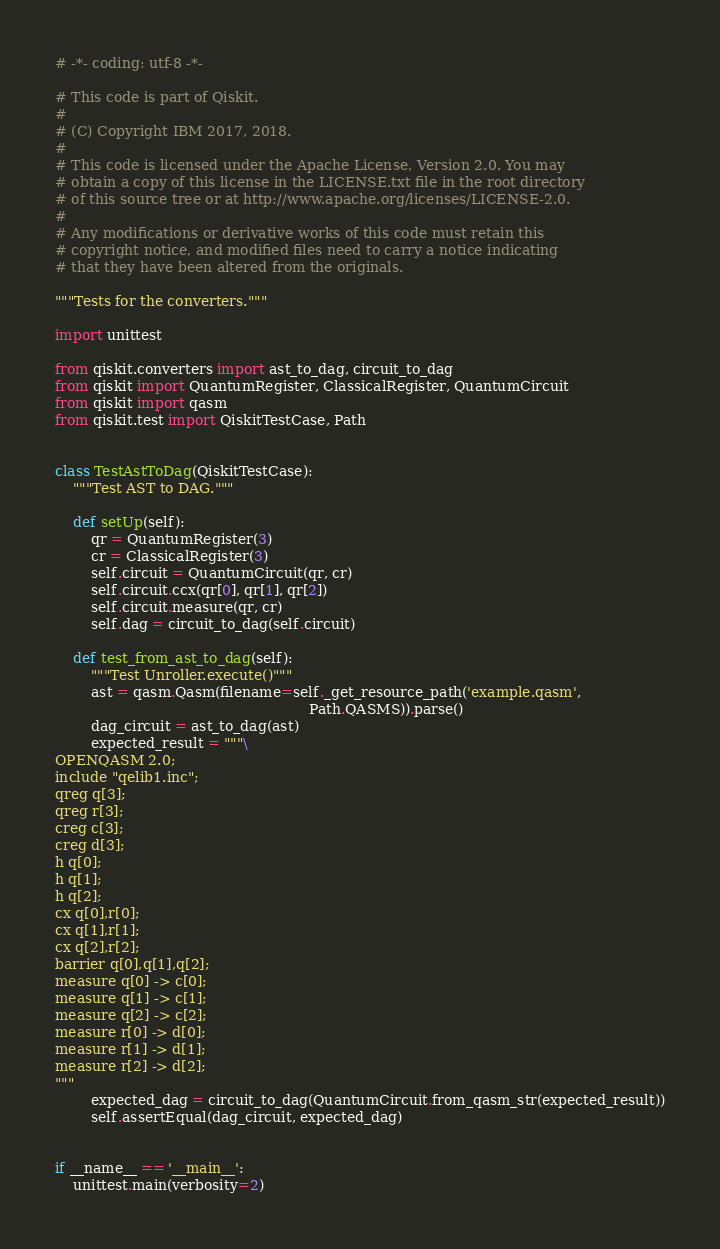Convert code to text. <code><loc_0><loc_0><loc_500><loc_500><_Python_># -*- coding: utf-8 -*-

# This code is part of Qiskit.
#
# (C) Copyright IBM 2017, 2018.
#
# This code is licensed under the Apache License, Version 2.0. You may
# obtain a copy of this license in the LICENSE.txt file in the root directory
# of this source tree or at http://www.apache.org/licenses/LICENSE-2.0.
#
# Any modifications or derivative works of this code must retain this
# copyright notice, and modified files need to carry a notice indicating
# that they have been altered from the originals.

"""Tests for the converters."""

import unittest

from qiskit.converters import ast_to_dag, circuit_to_dag
from qiskit import QuantumRegister, ClassicalRegister, QuantumCircuit
from qiskit import qasm
from qiskit.test import QiskitTestCase, Path


class TestAstToDag(QiskitTestCase):
    """Test AST to DAG."""

    def setUp(self):
        qr = QuantumRegister(3)
        cr = ClassicalRegister(3)
        self.circuit = QuantumCircuit(qr, cr)
        self.circuit.ccx(qr[0], qr[1], qr[2])
        self.circuit.measure(qr, cr)
        self.dag = circuit_to_dag(self.circuit)

    def test_from_ast_to_dag(self):
        """Test Unroller.execute()"""
        ast = qasm.Qasm(filename=self._get_resource_path('example.qasm',
                                                         Path.QASMS)).parse()
        dag_circuit = ast_to_dag(ast)
        expected_result = """\
OPENQASM 2.0;
include "qelib1.inc";
qreg q[3];
qreg r[3];
creg c[3];
creg d[3];
h q[0];
h q[1];
h q[2];
cx q[0],r[0];
cx q[1],r[1];
cx q[2],r[2];
barrier q[0],q[1],q[2];
measure q[0] -> c[0];
measure q[1] -> c[1];
measure q[2] -> c[2];
measure r[0] -> d[0];
measure r[1] -> d[1];
measure r[2] -> d[2];
"""
        expected_dag = circuit_to_dag(QuantumCircuit.from_qasm_str(expected_result))
        self.assertEqual(dag_circuit, expected_dag)


if __name__ == '__main__':
    unittest.main(verbosity=2)
</code> 